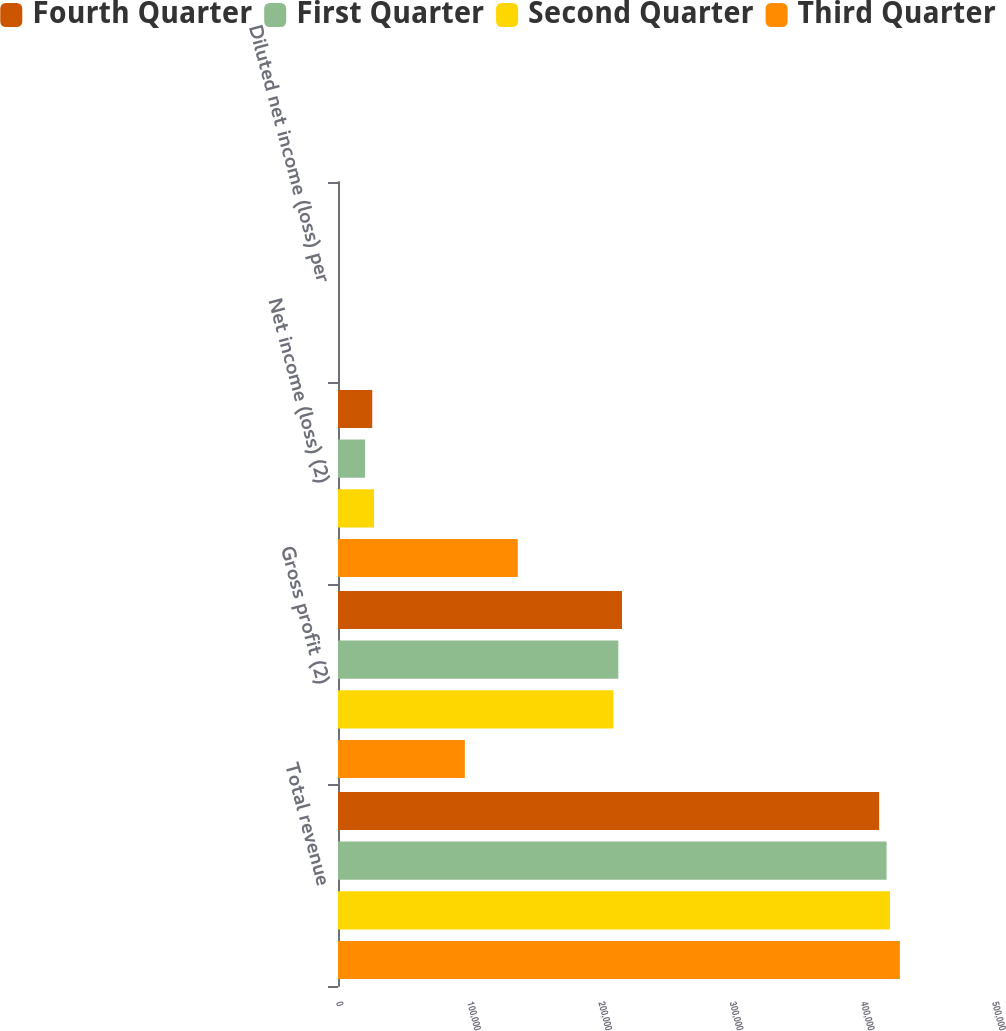Convert chart to OTSL. <chart><loc_0><loc_0><loc_500><loc_500><stacked_bar_chart><ecel><fcel>Total revenue<fcel>Gross profit (2)<fcel>Net income (loss) (2)<fcel>Diluted net income (loss) per<nl><fcel>Fourth Quarter<fcel>412448<fcel>216445<fcel>26095<fcel>0.1<nl><fcel>First Quarter<fcel>418112<fcel>213639<fcel>20618<fcel>0.08<nl><fcel>Second Quarter<fcel>420693<fcel>209889<fcel>27448<fcel>0.1<nl><fcel>Third Quarter<fcel>428299<fcel>96665<fcel>136974<fcel>0.53<nl></chart> 